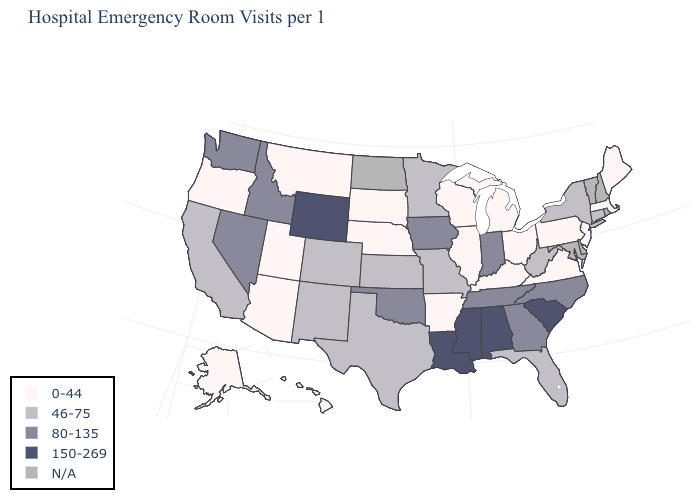What is the highest value in the MidWest ?
Short answer required. 80-135. What is the value of Louisiana?
Give a very brief answer. 150-269. What is the value of Kansas?
Keep it brief. 46-75. Name the states that have a value in the range N/A?
Concise answer only. Delaware, Maryland, New Hampshire, North Dakota, Rhode Island, Vermont. Among the states that border Maryland , does West Virginia have the lowest value?
Short answer required. No. Among the states that border Mississippi , does Louisiana have the highest value?
Answer briefly. Yes. Name the states that have a value in the range 150-269?
Short answer required. Alabama, Louisiana, Mississippi, South Carolina, Wyoming. Among the states that border Alabama , which have the lowest value?
Give a very brief answer. Florida. Does Massachusetts have the highest value in the Northeast?
Give a very brief answer. No. Name the states that have a value in the range N/A?
Quick response, please. Delaware, Maryland, New Hampshire, North Dakota, Rhode Island, Vermont. Among the states that border Ohio , does Indiana have the highest value?
Quick response, please. Yes. What is the value of Montana?
Give a very brief answer. 0-44. Does Wyoming have the highest value in the West?
Be succinct. Yes. What is the value of Colorado?
Keep it brief. 46-75. What is the highest value in states that border New York?
Concise answer only. 46-75. 